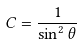Convert formula to latex. <formula><loc_0><loc_0><loc_500><loc_500>C = \frac { 1 } { \sin ^ { 2 } \theta }</formula> 